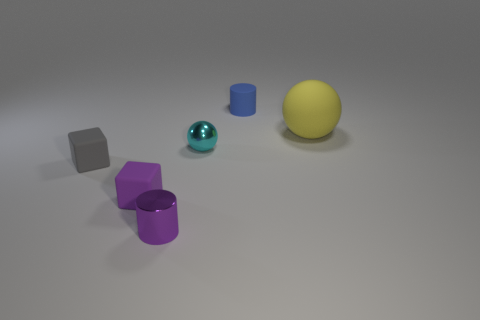How many small cylinders are both behind the small gray cube and in front of the blue cylinder?
Give a very brief answer. 0. Do the metallic object left of the tiny metal ball and the tiny matte block on the right side of the tiny gray thing have the same color?
Offer a terse response. Yes. There is a yellow rubber object that is the same shape as the tiny cyan shiny object; what is its size?
Ensure brevity in your answer.  Large. There is a gray object; are there any tiny matte things left of it?
Offer a very short reply. No. Is the number of gray rubber objects that are on the left side of the purple cylinder the same as the number of small gray objects?
Provide a succinct answer. Yes. Is there a cyan metal object that is right of the cylinder on the left side of the cylinder that is behind the small shiny sphere?
Offer a terse response. Yes. What material is the small ball?
Your answer should be very brief. Metal. What number of other things are the same shape as the tiny cyan metal thing?
Your response must be concise. 1. Is the shape of the large yellow thing the same as the cyan object?
Your answer should be compact. Yes. What number of things are either rubber cubes that are behind the purple metallic cylinder or small things that are on the right side of the purple matte thing?
Your answer should be compact. 5. 